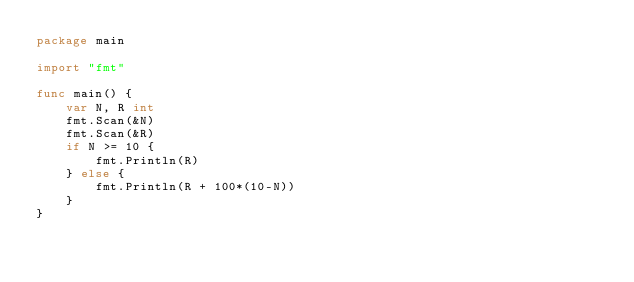Convert code to text. <code><loc_0><loc_0><loc_500><loc_500><_Go_>package main

import "fmt"

func main() {
	var N, R int
	fmt.Scan(&N)
	fmt.Scan(&R)
	if N >= 10 {
		fmt.Println(R)
	} else {
		fmt.Println(R + 100*(10-N))
	}
}
</code> 